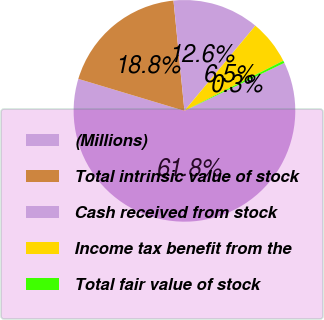<chart> <loc_0><loc_0><loc_500><loc_500><pie_chart><fcel>(Millions)<fcel>Total intrinsic value of stock<fcel>Cash received from stock<fcel>Income tax benefit from the<fcel>Total fair value of stock<nl><fcel>61.78%<fcel>18.77%<fcel>12.63%<fcel>6.48%<fcel>0.34%<nl></chart> 